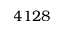Convert formula to latex. <formula><loc_0><loc_0><loc_500><loc_500>4 1 2 8</formula> 